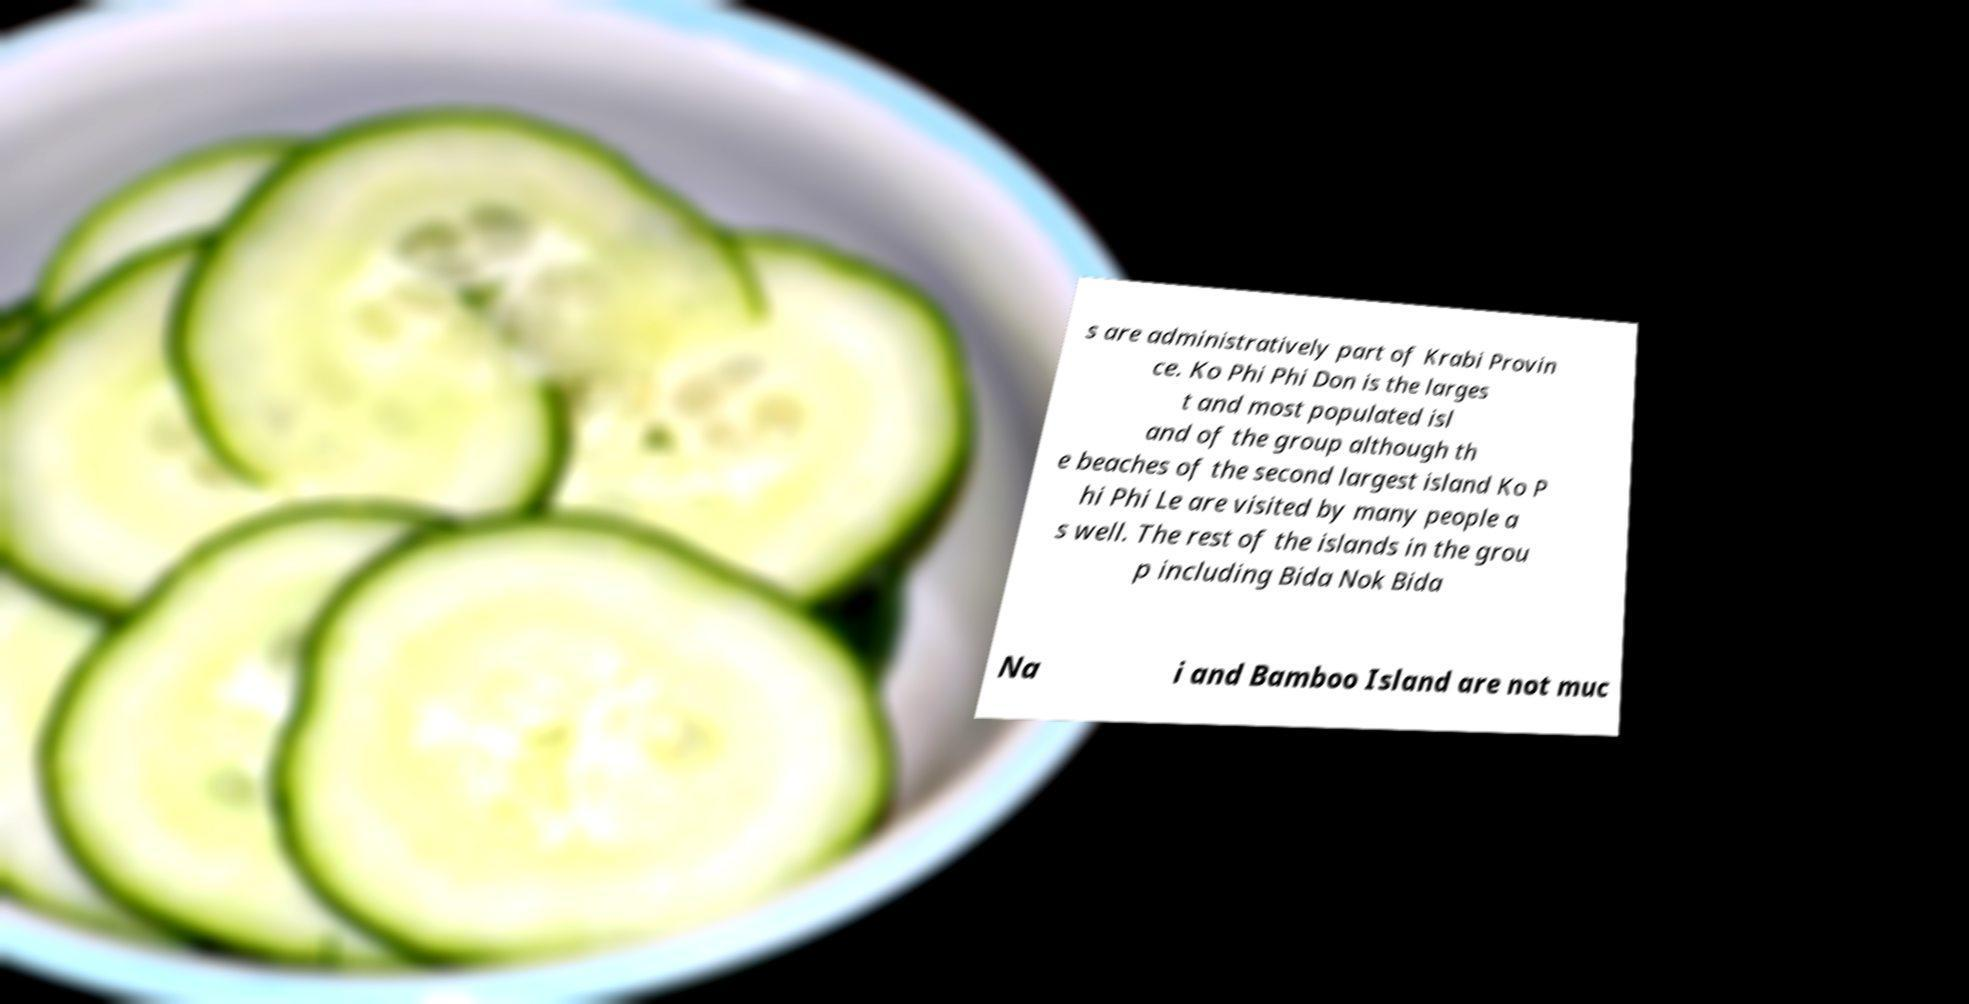There's text embedded in this image that I need extracted. Can you transcribe it verbatim? s are administratively part of Krabi Provin ce. Ko Phi Phi Don is the larges t and most populated isl and of the group although th e beaches of the second largest island Ko P hi Phi Le are visited by many people a s well. The rest of the islands in the grou p including Bida Nok Bida Na i and Bamboo Island are not muc 